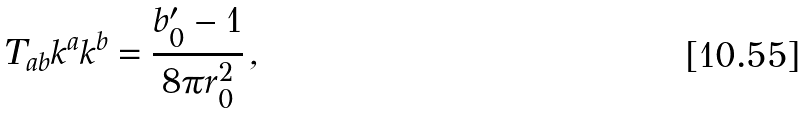<formula> <loc_0><loc_0><loc_500><loc_500>T _ { a b } k ^ { a } k ^ { b } = \frac { b _ { 0 } ^ { \prime } - 1 } { 8 \pi r _ { 0 } ^ { 2 } } \, ,</formula> 